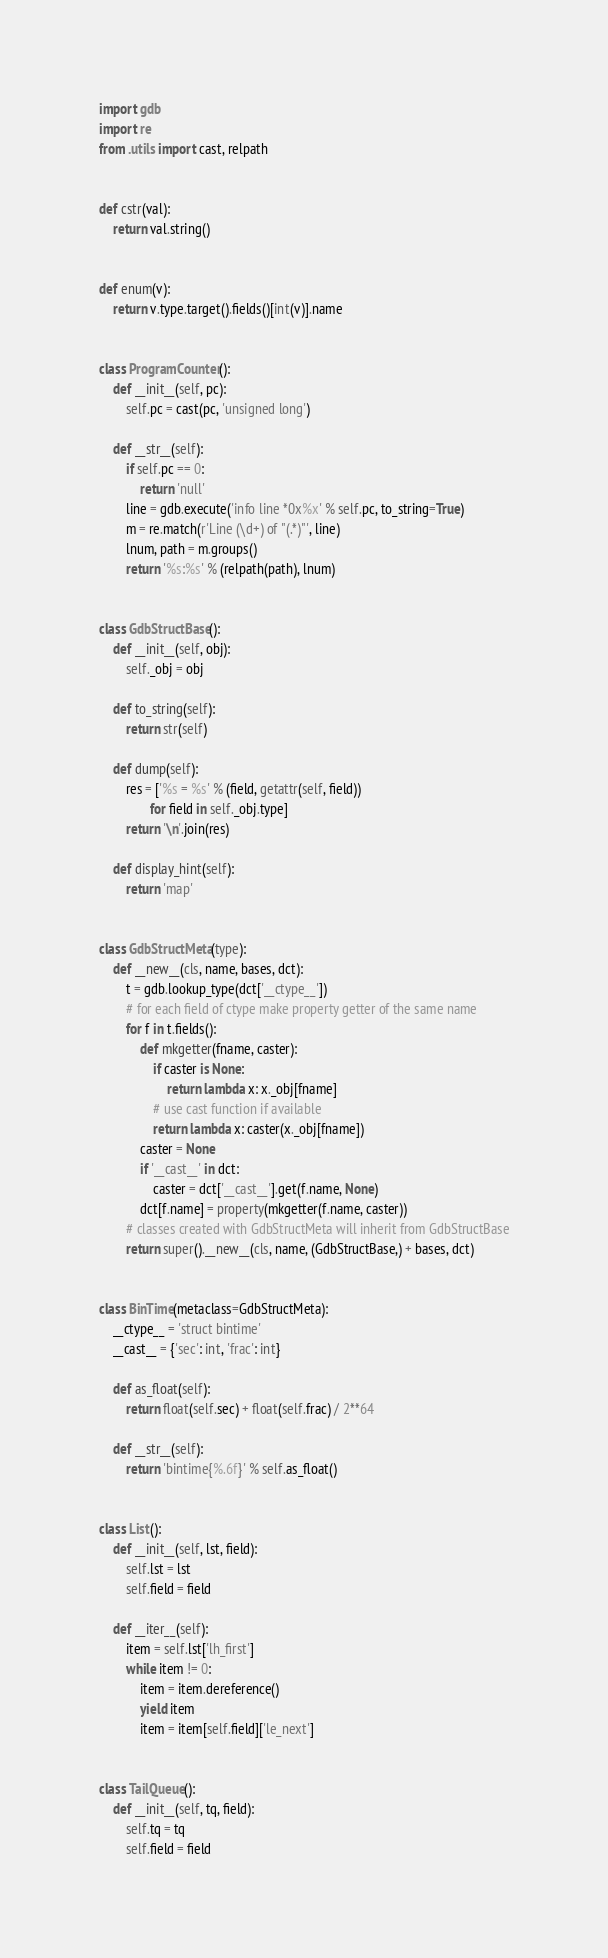<code> <loc_0><loc_0><loc_500><loc_500><_Python_>import gdb
import re
from .utils import cast, relpath


def cstr(val):
    return val.string()


def enum(v):
    return v.type.target().fields()[int(v)].name


class ProgramCounter():
    def __init__(self, pc):
        self.pc = cast(pc, 'unsigned long')

    def __str__(self):
        if self.pc == 0:
            return 'null'
        line = gdb.execute('info line *0x%x' % self.pc, to_string=True)
        m = re.match(r'Line (\d+) of "(.*)"', line)
        lnum, path = m.groups()
        return '%s:%s' % (relpath(path), lnum)


class GdbStructBase():
    def __init__(self, obj):
        self._obj = obj

    def to_string(self):
        return str(self)

    def dump(self):
        res = ['%s = %s' % (field, getattr(self, field))
               for field in self._obj.type]
        return '\n'.join(res)

    def display_hint(self):
        return 'map'


class GdbStructMeta(type):
    def __new__(cls, name, bases, dct):
        t = gdb.lookup_type(dct['__ctype__'])
        # for each field of ctype make property getter of the same name
        for f in t.fields():
            def mkgetter(fname, caster):
                if caster is None:
                    return lambda x: x._obj[fname]
                # use cast function if available
                return lambda x: caster(x._obj[fname])
            caster = None
            if '__cast__' in dct:
                caster = dct['__cast__'].get(f.name, None)
            dct[f.name] = property(mkgetter(f.name, caster))
        # classes created with GdbStructMeta will inherit from GdbStructBase
        return super().__new__(cls, name, (GdbStructBase,) + bases, dct)


class BinTime(metaclass=GdbStructMeta):
    __ctype__ = 'struct bintime'
    __cast__ = {'sec': int, 'frac': int}

    def as_float(self):
        return float(self.sec) + float(self.frac) / 2**64

    def __str__(self):
        return 'bintime{%.6f}' % self.as_float()


class List():
    def __init__(self, lst, field):
        self.lst = lst
        self.field = field

    def __iter__(self):
        item = self.lst['lh_first']
        while item != 0:
            item = item.dereference()
            yield item
            item = item[self.field]['le_next']


class TailQueue():
    def __init__(self, tq, field):
        self.tq = tq
        self.field = field
</code> 